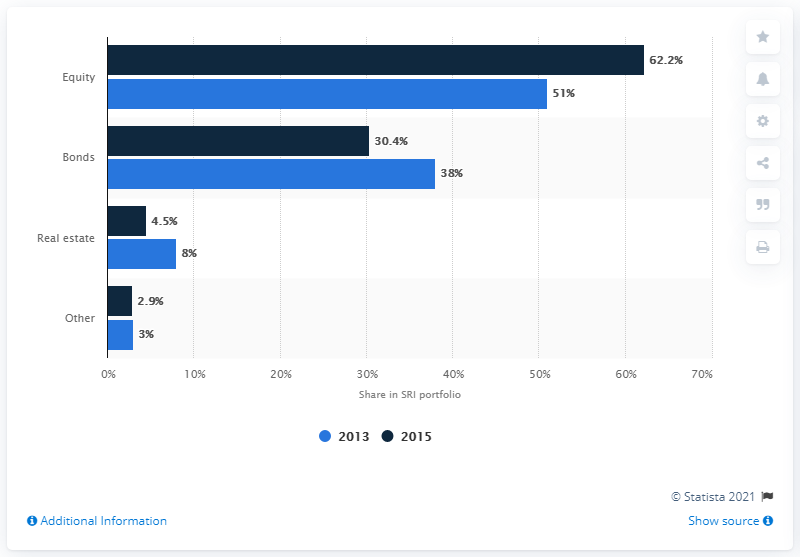Mention a couple of crucial points in this snapshot. In 2015, the average value of assets was 25. Equity has the highest level of investments compared to other assets. In 2015, the share of equity in the Swedish SRI portfolio was 62.2%. 